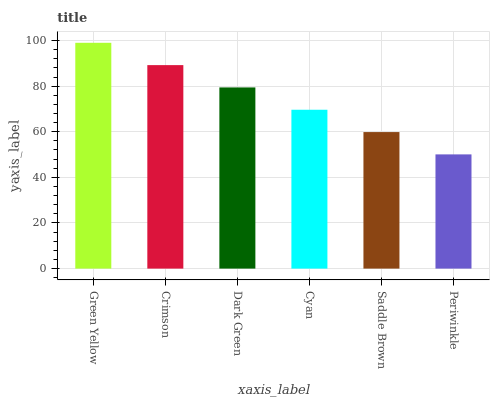Is Periwinkle the minimum?
Answer yes or no. Yes. Is Green Yellow the maximum?
Answer yes or no. Yes. Is Crimson the minimum?
Answer yes or no. No. Is Crimson the maximum?
Answer yes or no. No. Is Green Yellow greater than Crimson?
Answer yes or no. Yes. Is Crimson less than Green Yellow?
Answer yes or no. Yes. Is Crimson greater than Green Yellow?
Answer yes or no. No. Is Green Yellow less than Crimson?
Answer yes or no. No. Is Dark Green the high median?
Answer yes or no. Yes. Is Cyan the low median?
Answer yes or no. Yes. Is Saddle Brown the high median?
Answer yes or no. No. Is Saddle Brown the low median?
Answer yes or no. No. 